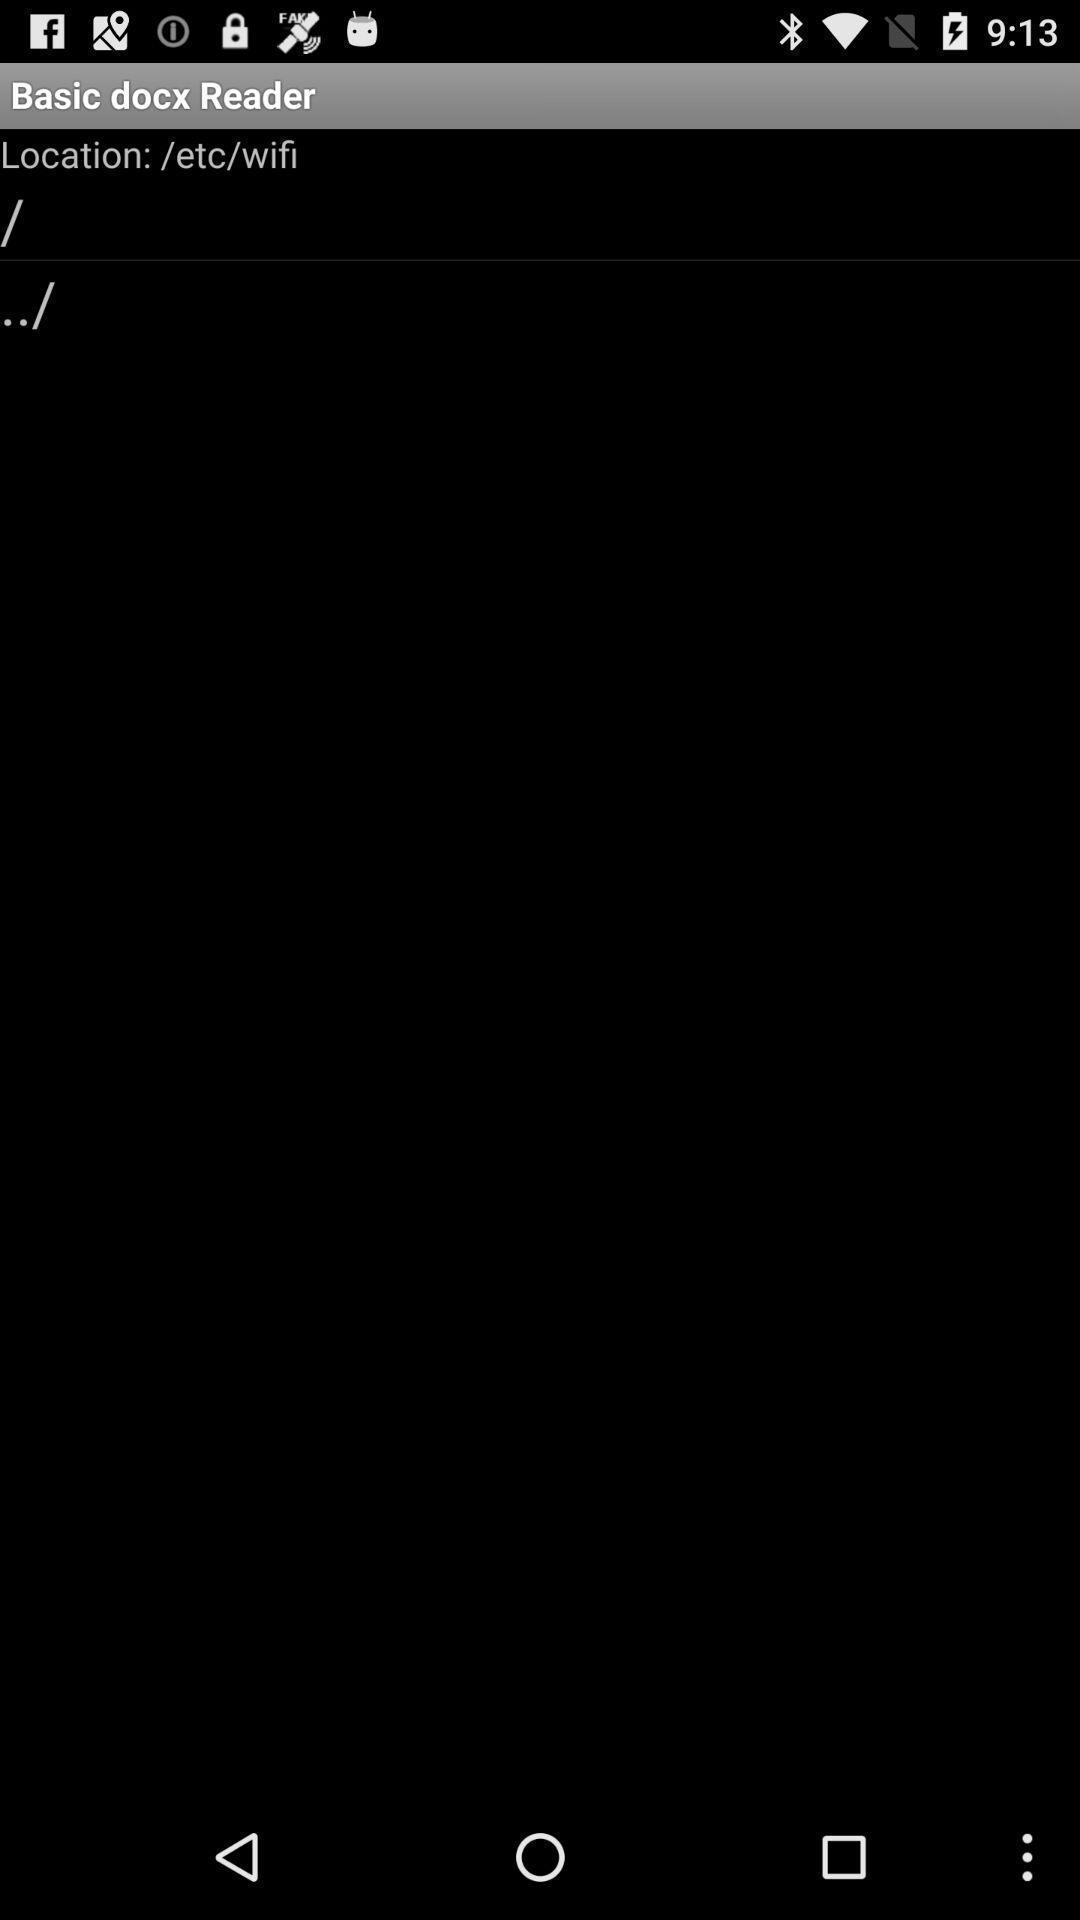Describe the content in this image. Screen shows a blank page. 